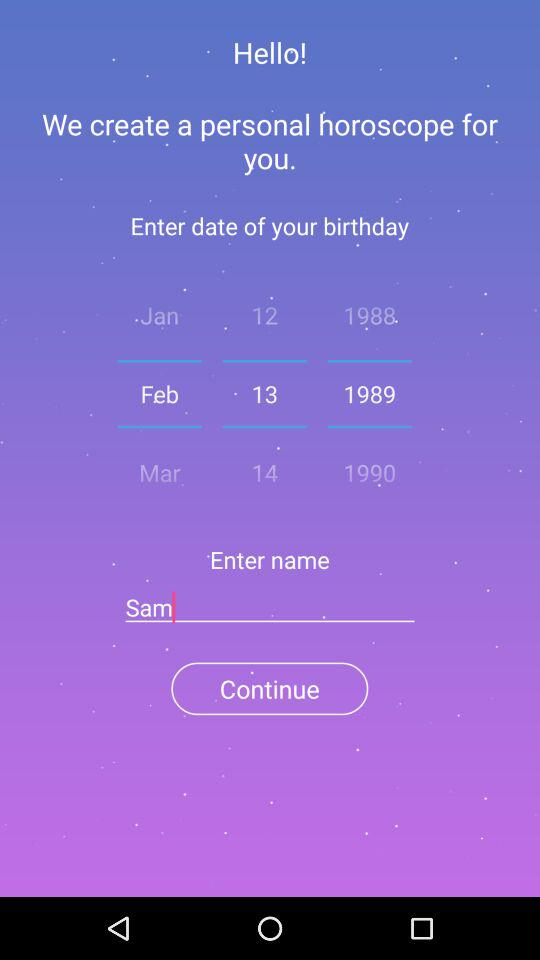What is the birthdate? The birthdate is February 13, 1989. 